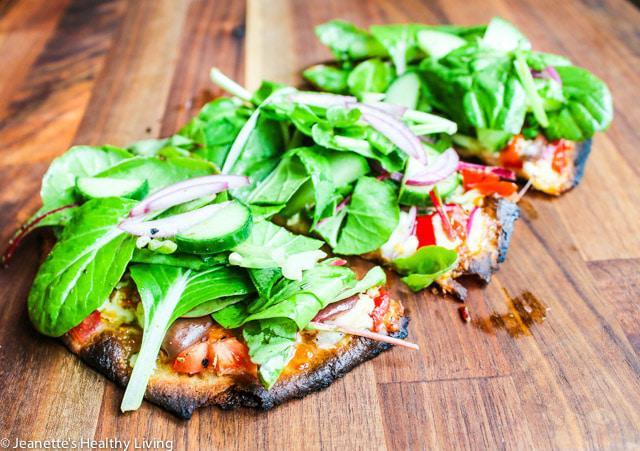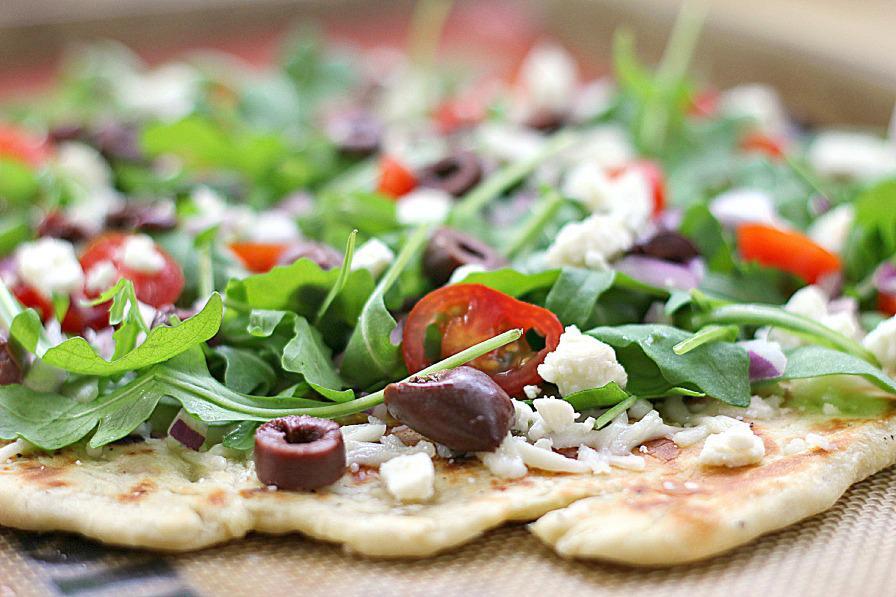The first image is the image on the left, the second image is the image on the right. For the images displayed, is the sentence "The left image contains a round pizza cut in four parts, with a yellowish pepper on top of each slice." factually correct? Answer yes or no. No. The first image is the image on the left, the second image is the image on the right. Assess this claim about the two images: "The left and right image contains the same number of circle shaped pizzas.". Correct or not? Answer yes or no. No. 